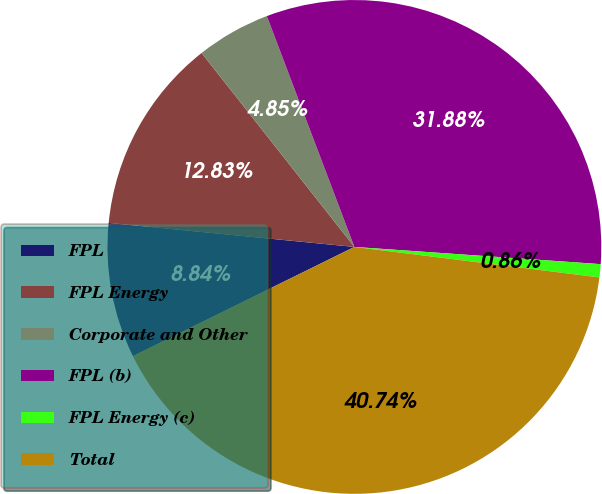<chart> <loc_0><loc_0><loc_500><loc_500><pie_chart><fcel>FPL<fcel>FPL Energy<fcel>Corporate and Other<fcel>FPL (b)<fcel>FPL Energy (c)<fcel>Total<nl><fcel>8.84%<fcel>12.83%<fcel>4.85%<fcel>31.88%<fcel>0.86%<fcel>40.74%<nl></chart> 